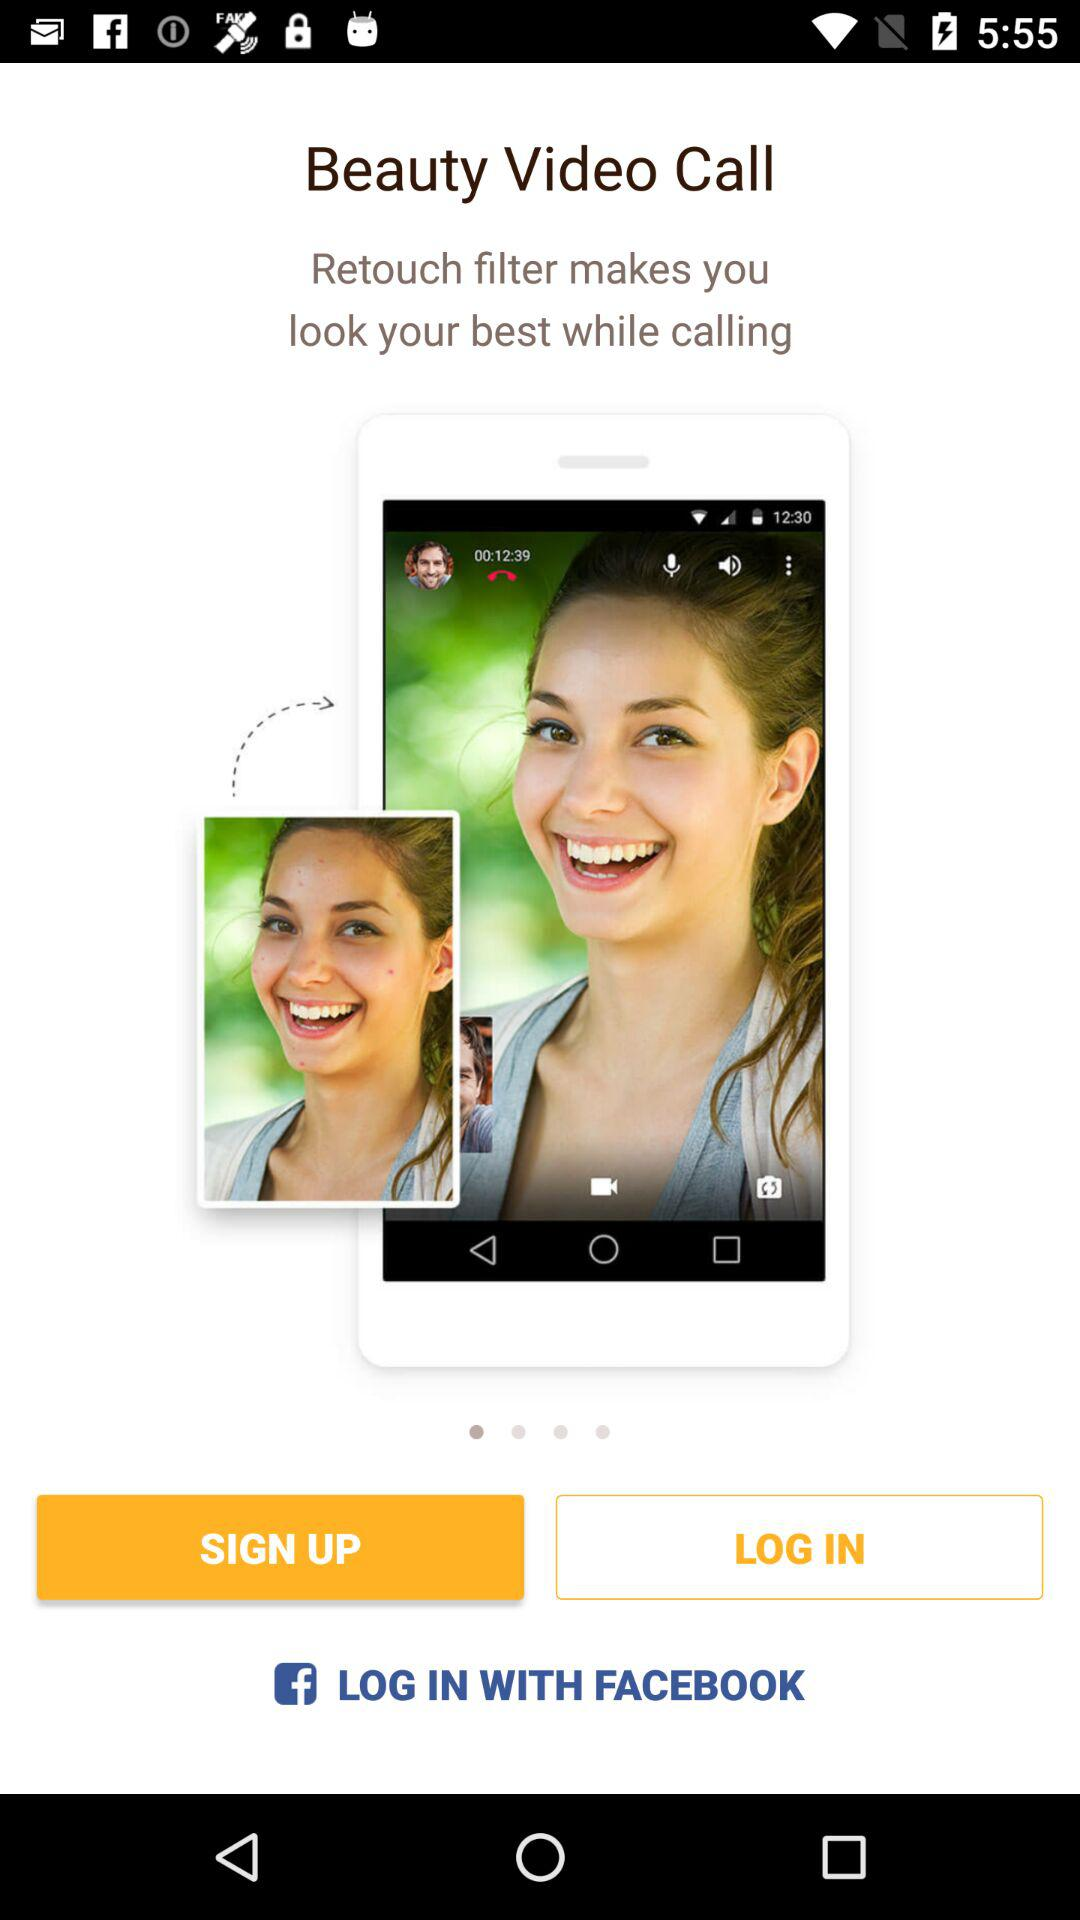What applications can be used to log in? The application that can be used to log in is "FACEBOOK". 